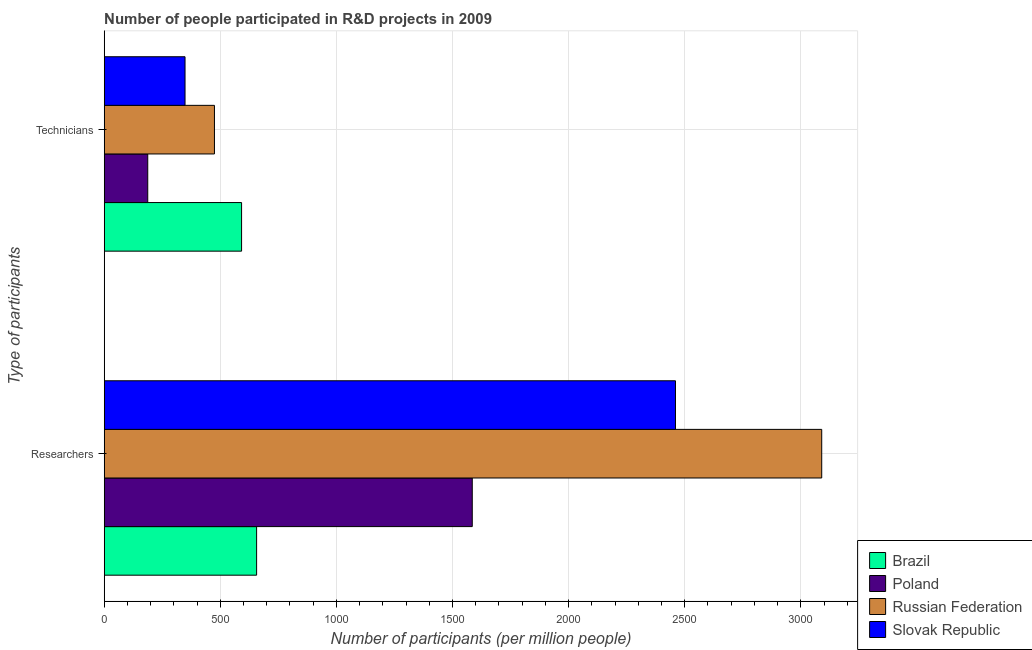How many different coloured bars are there?
Your answer should be compact. 4. How many groups of bars are there?
Offer a very short reply. 2. Are the number of bars on each tick of the Y-axis equal?
Offer a very short reply. Yes. How many bars are there on the 2nd tick from the bottom?
Make the answer very short. 4. What is the label of the 1st group of bars from the top?
Provide a short and direct response. Technicians. What is the number of researchers in Russian Federation?
Ensure brevity in your answer.  3090.01. Across all countries, what is the maximum number of technicians?
Your answer should be compact. 591.57. Across all countries, what is the minimum number of researchers?
Your answer should be compact. 656.34. In which country was the number of researchers maximum?
Offer a very short reply. Russian Federation. In which country was the number of technicians minimum?
Offer a very short reply. Poland. What is the total number of researchers in the graph?
Your answer should be compact. 7791.59. What is the difference between the number of researchers in Russian Federation and that in Poland?
Your answer should be compact. 1504.99. What is the difference between the number of technicians in Slovak Republic and the number of researchers in Russian Federation?
Your response must be concise. -2741.95. What is the average number of technicians per country?
Give a very brief answer. 400.48. What is the difference between the number of researchers and number of technicians in Brazil?
Your response must be concise. 64.76. In how many countries, is the number of technicians greater than 1900 ?
Give a very brief answer. 0. What is the ratio of the number of researchers in Russian Federation to that in Slovak Republic?
Provide a short and direct response. 1.26. What does the 4th bar from the top in Researchers represents?
Provide a succinct answer. Brazil. What does the 4th bar from the bottom in Researchers represents?
Your response must be concise. Slovak Republic. How many bars are there?
Offer a very short reply. 8. Are all the bars in the graph horizontal?
Offer a very short reply. Yes. Does the graph contain grids?
Give a very brief answer. Yes. How many legend labels are there?
Provide a succinct answer. 4. How are the legend labels stacked?
Provide a succinct answer. Vertical. What is the title of the graph?
Make the answer very short. Number of people participated in R&D projects in 2009. What is the label or title of the X-axis?
Your response must be concise. Number of participants (per million people). What is the label or title of the Y-axis?
Keep it short and to the point. Type of participants. What is the Number of participants (per million people) of Brazil in Researchers?
Make the answer very short. 656.34. What is the Number of participants (per million people) in Poland in Researchers?
Keep it short and to the point. 1585.02. What is the Number of participants (per million people) of Russian Federation in Researchers?
Your answer should be compact. 3090.01. What is the Number of participants (per million people) of Slovak Republic in Researchers?
Your answer should be compact. 2460.22. What is the Number of participants (per million people) of Brazil in Technicians?
Give a very brief answer. 591.57. What is the Number of participants (per million people) of Poland in Technicians?
Give a very brief answer. 187.5. What is the Number of participants (per million people) of Russian Federation in Technicians?
Provide a succinct answer. 474.78. What is the Number of participants (per million people) of Slovak Republic in Technicians?
Keep it short and to the point. 348.06. Across all Type of participants, what is the maximum Number of participants (per million people) in Brazil?
Keep it short and to the point. 656.34. Across all Type of participants, what is the maximum Number of participants (per million people) of Poland?
Ensure brevity in your answer.  1585.02. Across all Type of participants, what is the maximum Number of participants (per million people) in Russian Federation?
Provide a short and direct response. 3090.01. Across all Type of participants, what is the maximum Number of participants (per million people) in Slovak Republic?
Provide a short and direct response. 2460.22. Across all Type of participants, what is the minimum Number of participants (per million people) in Brazil?
Offer a terse response. 591.57. Across all Type of participants, what is the minimum Number of participants (per million people) in Poland?
Keep it short and to the point. 187.5. Across all Type of participants, what is the minimum Number of participants (per million people) of Russian Federation?
Offer a very short reply. 474.78. Across all Type of participants, what is the minimum Number of participants (per million people) in Slovak Republic?
Make the answer very short. 348.06. What is the total Number of participants (per million people) of Brazil in the graph?
Your response must be concise. 1247.91. What is the total Number of participants (per million people) of Poland in the graph?
Your answer should be very brief. 1772.53. What is the total Number of participants (per million people) of Russian Federation in the graph?
Provide a short and direct response. 3564.79. What is the total Number of participants (per million people) in Slovak Republic in the graph?
Your response must be concise. 2808.28. What is the difference between the Number of participants (per million people) in Brazil in Researchers and that in Technicians?
Provide a short and direct response. 64.76. What is the difference between the Number of participants (per million people) in Poland in Researchers and that in Technicians?
Keep it short and to the point. 1397.52. What is the difference between the Number of participants (per million people) of Russian Federation in Researchers and that in Technicians?
Provide a short and direct response. 2615.24. What is the difference between the Number of participants (per million people) of Slovak Republic in Researchers and that in Technicians?
Your answer should be compact. 2112.16. What is the difference between the Number of participants (per million people) in Brazil in Researchers and the Number of participants (per million people) in Poland in Technicians?
Give a very brief answer. 468.83. What is the difference between the Number of participants (per million people) in Brazil in Researchers and the Number of participants (per million people) in Russian Federation in Technicians?
Offer a terse response. 181.56. What is the difference between the Number of participants (per million people) in Brazil in Researchers and the Number of participants (per million people) in Slovak Republic in Technicians?
Keep it short and to the point. 308.28. What is the difference between the Number of participants (per million people) in Poland in Researchers and the Number of participants (per million people) in Russian Federation in Technicians?
Make the answer very short. 1110.25. What is the difference between the Number of participants (per million people) of Poland in Researchers and the Number of participants (per million people) of Slovak Republic in Technicians?
Provide a short and direct response. 1236.96. What is the difference between the Number of participants (per million people) of Russian Federation in Researchers and the Number of participants (per million people) of Slovak Republic in Technicians?
Your answer should be very brief. 2741.95. What is the average Number of participants (per million people) of Brazil per Type of participants?
Make the answer very short. 623.95. What is the average Number of participants (per million people) in Poland per Type of participants?
Keep it short and to the point. 886.26. What is the average Number of participants (per million people) in Russian Federation per Type of participants?
Give a very brief answer. 1782.39. What is the average Number of participants (per million people) of Slovak Republic per Type of participants?
Your response must be concise. 1404.14. What is the difference between the Number of participants (per million people) in Brazil and Number of participants (per million people) in Poland in Researchers?
Your answer should be compact. -928.69. What is the difference between the Number of participants (per million people) of Brazil and Number of participants (per million people) of Russian Federation in Researchers?
Make the answer very short. -2433.68. What is the difference between the Number of participants (per million people) of Brazil and Number of participants (per million people) of Slovak Republic in Researchers?
Ensure brevity in your answer.  -1803.89. What is the difference between the Number of participants (per million people) of Poland and Number of participants (per million people) of Russian Federation in Researchers?
Your answer should be very brief. -1504.99. What is the difference between the Number of participants (per million people) in Poland and Number of participants (per million people) in Slovak Republic in Researchers?
Offer a terse response. -875.2. What is the difference between the Number of participants (per million people) of Russian Federation and Number of participants (per million people) of Slovak Republic in Researchers?
Offer a terse response. 629.79. What is the difference between the Number of participants (per million people) of Brazil and Number of participants (per million people) of Poland in Technicians?
Ensure brevity in your answer.  404.07. What is the difference between the Number of participants (per million people) of Brazil and Number of participants (per million people) of Russian Federation in Technicians?
Offer a very short reply. 116.8. What is the difference between the Number of participants (per million people) of Brazil and Number of participants (per million people) of Slovak Republic in Technicians?
Provide a succinct answer. 243.51. What is the difference between the Number of participants (per million people) in Poland and Number of participants (per million people) in Russian Federation in Technicians?
Provide a short and direct response. -287.27. What is the difference between the Number of participants (per million people) in Poland and Number of participants (per million people) in Slovak Republic in Technicians?
Ensure brevity in your answer.  -160.56. What is the difference between the Number of participants (per million people) in Russian Federation and Number of participants (per million people) in Slovak Republic in Technicians?
Give a very brief answer. 126.72. What is the ratio of the Number of participants (per million people) of Brazil in Researchers to that in Technicians?
Offer a very short reply. 1.11. What is the ratio of the Number of participants (per million people) in Poland in Researchers to that in Technicians?
Provide a short and direct response. 8.45. What is the ratio of the Number of participants (per million people) in Russian Federation in Researchers to that in Technicians?
Give a very brief answer. 6.51. What is the ratio of the Number of participants (per million people) in Slovak Republic in Researchers to that in Technicians?
Provide a succinct answer. 7.07. What is the difference between the highest and the second highest Number of participants (per million people) of Brazil?
Your answer should be very brief. 64.76. What is the difference between the highest and the second highest Number of participants (per million people) in Poland?
Offer a terse response. 1397.52. What is the difference between the highest and the second highest Number of participants (per million people) of Russian Federation?
Provide a short and direct response. 2615.24. What is the difference between the highest and the second highest Number of participants (per million people) in Slovak Republic?
Your response must be concise. 2112.16. What is the difference between the highest and the lowest Number of participants (per million people) in Brazil?
Make the answer very short. 64.76. What is the difference between the highest and the lowest Number of participants (per million people) in Poland?
Provide a short and direct response. 1397.52. What is the difference between the highest and the lowest Number of participants (per million people) in Russian Federation?
Provide a succinct answer. 2615.24. What is the difference between the highest and the lowest Number of participants (per million people) in Slovak Republic?
Make the answer very short. 2112.16. 